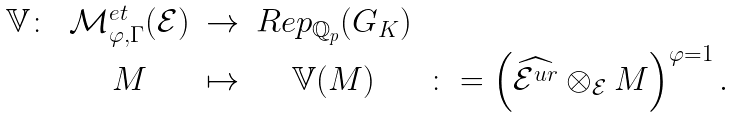Convert formula to latex. <formula><loc_0><loc_0><loc_500><loc_500>\begin{matrix} \mathbb { V } \colon & \mathcal { M } _ { \varphi , \Gamma } ^ { e t } ( \mathcal { E } ) & \to & R e p _ { \mathbb { Q } _ { p } } ( G _ { K } ) & \\ & M & \mapsto & \mathbb { V } ( M ) & \colon = \left ( \widehat { \mathcal { E } ^ { u r } } \otimes _ { \mathcal { E } } M \right ) ^ { \varphi = 1 } . \end{matrix}</formula> 